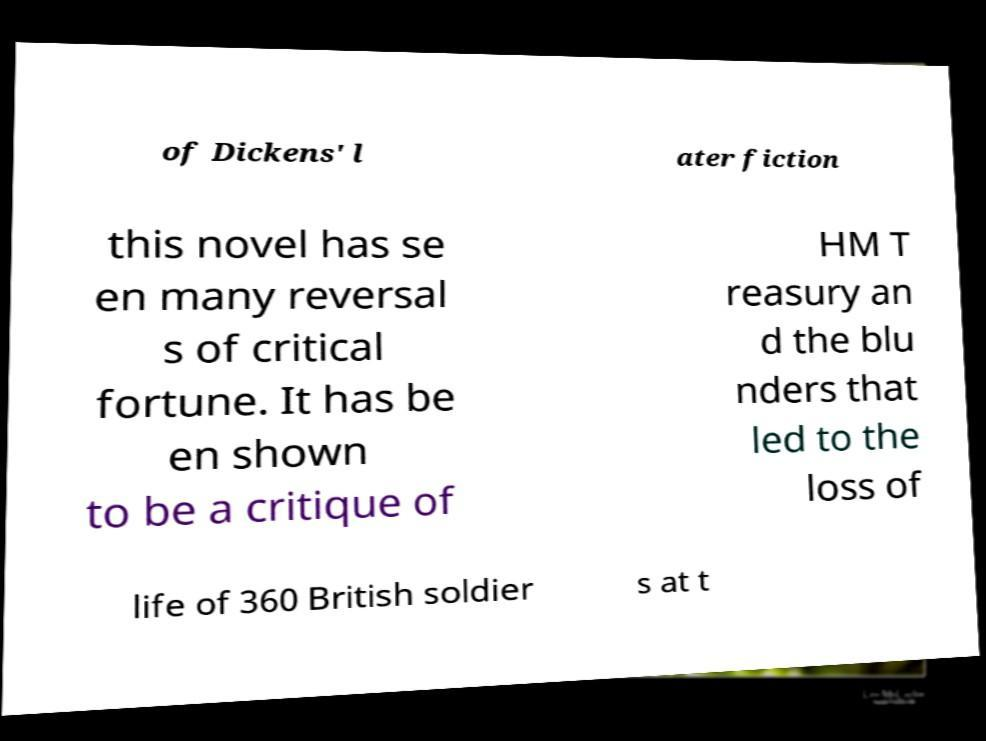For documentation purposes, I need the text within this image transcribed. Could you provide that? of Dickens' l ater fiction this novel has se en many reversal s of critical fortune. It has be en shown to be a critique of HM T reasury an d the blu nders that led to the loss of life of 360 British soldier s at t 